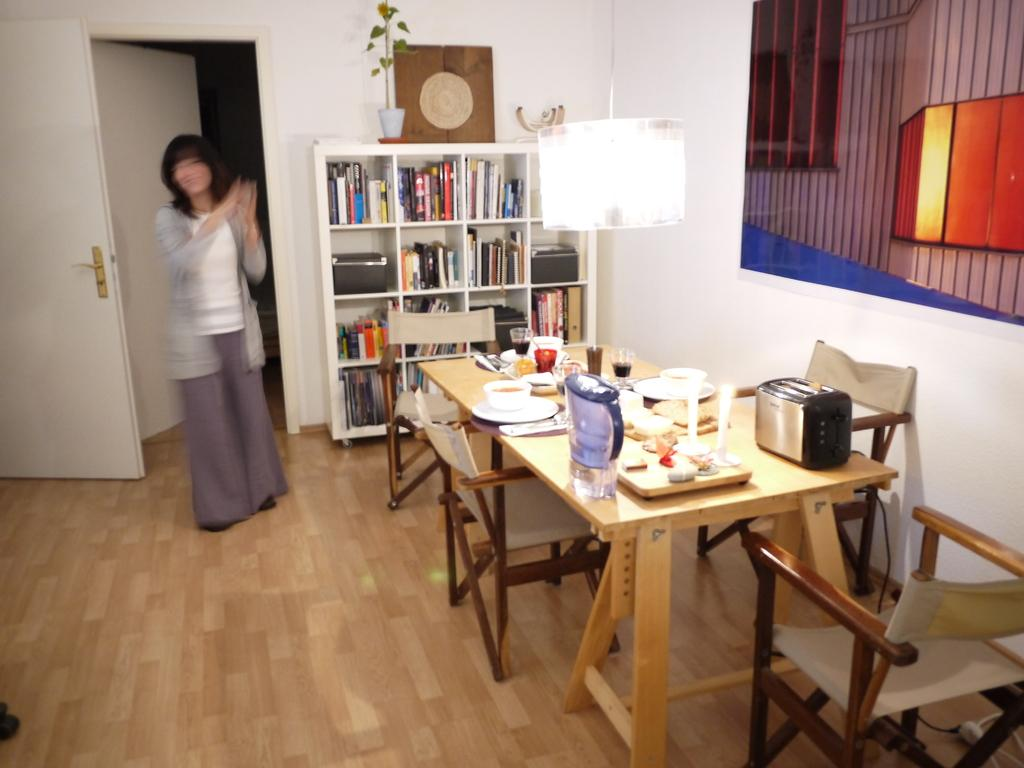What type of furniture is present in the image? There are tables and chairs in the image. What type of lighting is present in the image? There is a lamp in the image. What type of storage is present in the image? There is a bookshelf with many books in the image. Can you describe the blurred image on the left side of the image? There is a blurred image of a woman on the left side of the image. How many wings can be seen on the woman in the blurred image? There are no wings visible on the woman in the blurred image. What is the woman's mindset in the image? The image is blurred, so it is impossible to determine the woman's mindset. 